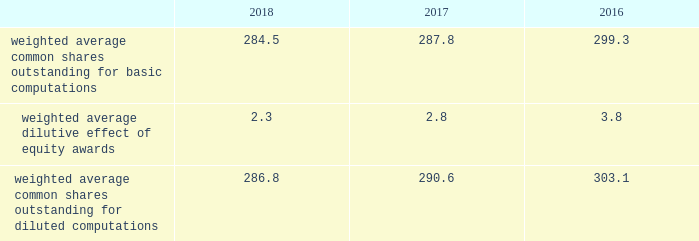Note 2 2013 earnings per share the weighted average number of shares outstanding used to compute earnings per common share were as follows ( in millions ) : .
We compute basic and diluted earnings per common share by dividing net earnings by the respective weighted average number of common shares outstanding for the periods presented .
Our calculation of diluted earnings per common share also includes the dilutive effects for the assumed vesting of outstanding restricted stock units ( rsus ) , performance stock units ( psus ) and exercise of outstanding stock options based on the treasury stock method .
There were no significant anti-dilutive equity awards for the years ended december 31 , 2018 , 2017 and 2016 .
Note 3 2013 acquisition and divestitures consolidation of awe management limited on august 24 , 2016 , we increased our ownership interest in the awe joint venture , which operates the united kingdom 2019s nuclear deterrent program , from 33% ( 33 % ) to 51% ( 51 % ) .
Consequently , we began consolidating awe and our operating results include 100% ( 100 % ) of awe 2019s sales and 51% ( 51 % ) of its operating profit .
Prior to increasing our ownership interest , we accounted for our investment in awe using the equity method of accounting .
Under the equity method , we recognized only 33% ( 33 % ) of awe 2019s earnings or losses and no sales .
Accordingly , prior to august 24 , 2016 , the date we obtained control , we recorded 33% ( 33 % ) of awe 2019s net earnings in our operating results and subsequent to august 24 , 2016 , we recognized 100% ( 100 % ) of awe 2019s sales and 51% ( 51 % ) of its operating profit .
We accounted for this transaction as a 201cstep acquisition 201d ( as defined by u.s .
Gaap ) , which requires us to consolidate and record the assets and liabilities of awe at fair value .
Accordingly , we recorded intangible assets of $ 243 million related to customer relationships , $ 32 million of net liabilities , and noncontrolling interests of $ 107 million .
The intangible assets are being amortized over a period of eight years in accordance with the underlying pattern of economic benefit reflected by the future net cash flows .
In 2016 , we recognized a non-cash net gain of $ 104 million associated with obtaining a controlling interest in awe , which consisted of a $ 127 million pretax gain recognized in the operating results of our space business segment and $ 23 million of tax-related items at our corporate office .
The gain represented the fair value of our 51% ( 51 % ) interest in awe , less the carrying value of our previously held investment in awe and deferred taxes .
The gain was recorded in other income , net on our consolidated statements of earnings .
The fair value of awe ( including the intangible assets ) , our controlling interest , and the noncontrolling interests were determined using the income approach .
Divestiture of the information systems & global solutions business on august 16 , 2016 , we divested our former is&gs business , which merged with leidos , in a reverse morris trust transaction ( the 201ctransaction 201d ) .
The transaction was completed in a multi-step process pursuant to which we initially contributed the is&gs business to abacus innovations corporation ( abacus ) , a wholly owned subsidiary of lockheed martin created to facilitate the transaction , and the common stock of abacus was distributed to participating lockheed martin stockholders through an exchange offer .
Under the terms of the exchange offer , lockheed martin stockholders had the option to exchange shares of lockheed martin common stock for shares of abacus common stock .
At the conclusion of the exchange offer , all shares of abacus common stock were exchanged for 9369694 shares of lockheed martin common stock held by lockheed martin stockholders that elected to participate in the exchange .
The shares of lockheed martin common stock that were exchanged and accepted were retired , reducing the number of shares of our common stock outstanding by approximately 3% ( 3 % ) .
Following the exchange offer , abacus merged with a subsidiary of leidos , with abacus continuing as the surviving corporation and a wholly-owned subsidiary of leidos .
As part of the merger , each share of abacus common stock was automatically converted into one share of leidos common stock .
We did not receive any shares of leidos common stock as part of the transaction and do not hold any shares of leidos or abacus common stock following the transaction .
Based on an opinion of outside tax counsel , subject to customary qualifications and based on factual representations , the exchange offer and merger will qualify as tax-free transactions to lockheed martin and its stockholders , except to the extent that cash was paid to lockheed martin stockholders in lieu of fractional shares .
In connection with the transaction , abacus borrowed an aggregate principal amount of approximately $ 1.84 billion under term loan facilities with third party financial institutions , the proceeds of which were used to make a one-time special cash payment of $ 1.80 billion to lockheed martin and to pay associated borrowing fees and expenses .
The entire special cash payment was used to repay debt , pay dividends and repurchase stock during the third and fourth quarters of 2016 .
The obligations under the abacus term loan facilities were guaranteed by leidos as part of the transaction. .
What was the change in the weighted average common shares outstanding for diluted computations from 2017 to 2018? 
Computations: ((286.8 - 290.6) / 290.6)
Answer: -0.01308. 